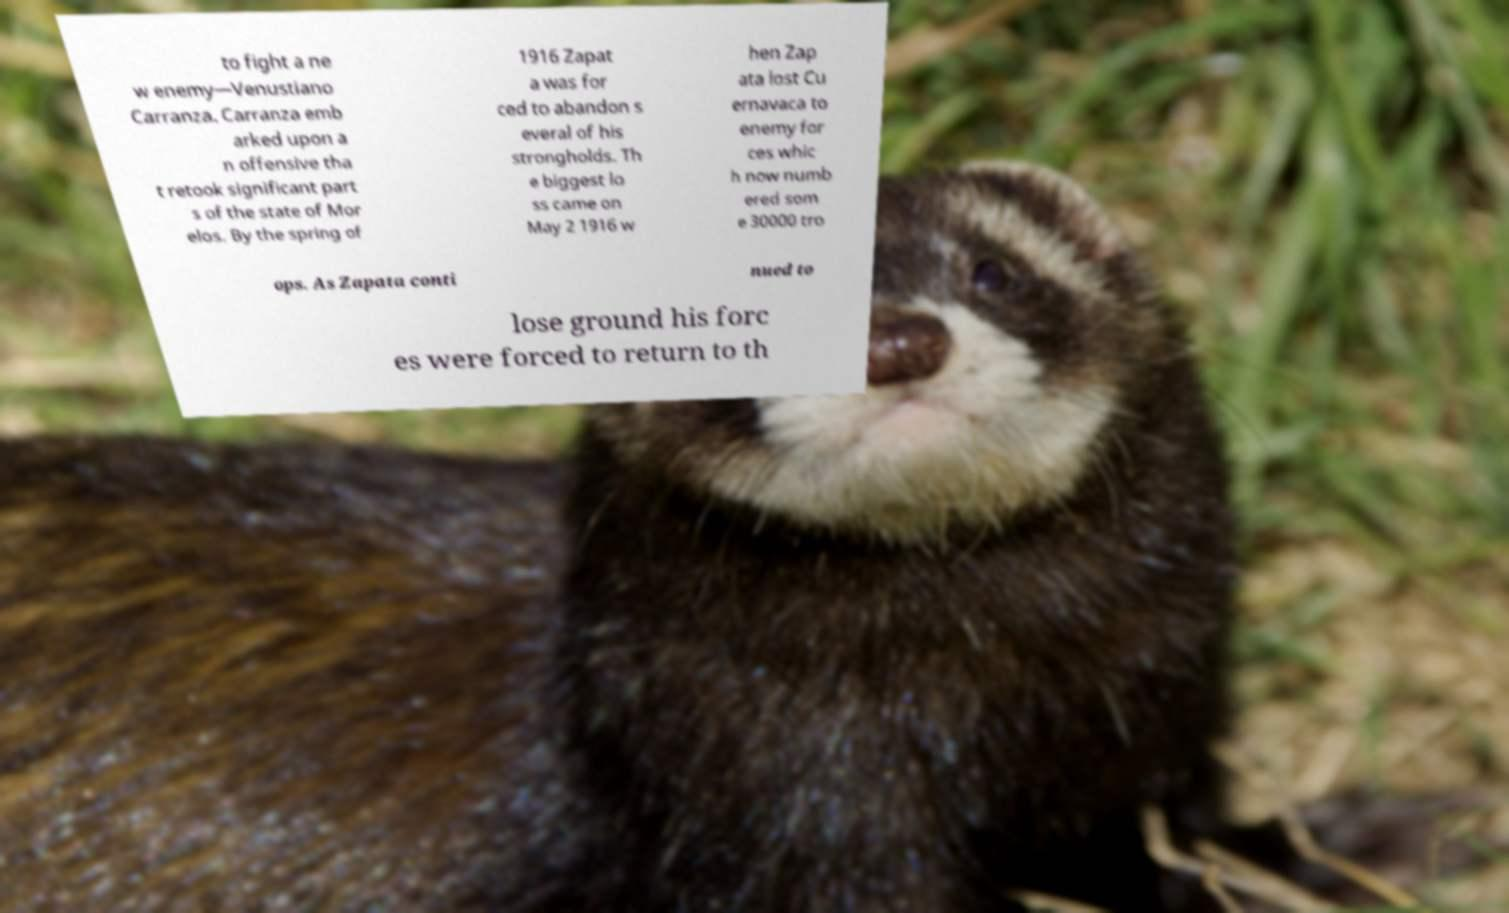Can you accurately transcribe the text from the provided image for me? to fight a ne w enemy—Venustiano Carranza. Carranza emb arked upon a n offensive tha t retook significant part s of the state of Mor elos. By the spring of 1916 Zapat a was for ced to abandon s everal of his strongholds. Th e biggest lo ss came on May 2 1916 w hen Zap ata lost Cu ernavaca to enemy for ces whic h now numb ered som e 30000 tro ops. As Zapata conti nued to lose ground his forc es were forced to return to th 